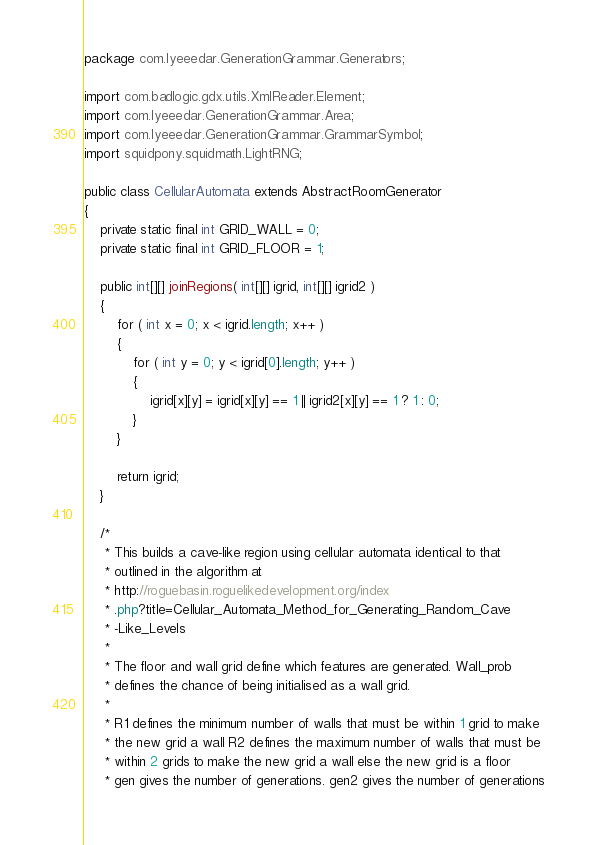Convert code to text. <code><loc_0><loc_0><loc_500><loc_500><_Java_>package com.lyeeedar.GenerationGrammar.Generators;

import com.badlogic.gdx.utils.XmlReader.Element;
import com.lyeeedar.GenerationGrammar.Area;
import com.lyeeedar.GenerationGrammar.GrammarSymbol;
import squidpony.squidmath.LightRNG;

public class CellularAutomata extends AbstractRoomGenerator
{
	private static final int GRID_WALL = 0;
	private static final int GRID_FLOOR = 1;

	public int[][] joinRegions( int[][] igrid, int[][] igrid2 )
	{
		for ( int x = 0; x < igrid.length; x++ )
		{
			for ( int y = 0; y < igrid[0].length; y++ )
			{
				igrid[x][y] = igrid[x][y] == 1 || igrid2[x][y] == 1 ? 1 : 0;
			}
		}

		return igrid;
	}

	/*
	 * This builds a cave-like region using cellular automata identical to that
	 * outlined in the algorithm at
	 * http://roguebasin.roguelikedevelopment.org/index
	 * .php?title=Cellular_Automata_Method_for_Generating_Random_Cave
	 * -Like_Levels
	 *
	 * The floor and wall grid define which features are generated. Wall_prob
	 * defines the chance of being initialised as a wall grid.
	 *
	 * R1 defines the minimum number of walls that must be within 1 grid to make
	 * the new grid a wall R2 defines the maximum number of walls that must be
	 * within 2 grids to make the new grid a wall else the new grid is a floor
	 * gen gives the number of generations. gen2 gives the number of generations</code> 